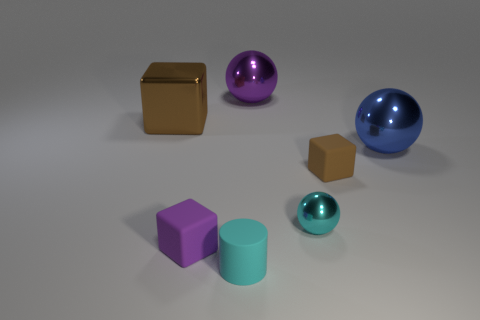What number of purple objects are both in front of the large brown thing and to the right of the tiny cyan matte cylinder?
Give a very brief answer. 0. There is a purple thing that is behind the large blue shiny ball; is it the same size as the cube behind the big blue metallic sphere?
Your response must be concise. Yes. There is a metallic object that is behind the large brown metal cube; what is its size?
Your response must be concise. Large. What number of things are shiny balls that are behind the large shiny block or matte objects on the right side of the purple cube?
Make the answer very short. 3. Is there any other thing that has the same color as the cylinder?
Offer a very short reply. Yes. Are there an equal number of tiny cubes that are behind the large blue object and brown cubes that are on the left side of the small cyan rubber thing?
Your response must be concise. No. Are there more small blocks on the right side of the cyan ball than small green matte cubes?
Offer a terse response. Yes. What number of objects are either cyan objects that are behind the purple rubber thing or cyan metallic spheres?
Provide a succinct answer. 1. How many large brown things are made of the same material as the tiny purple block?
Offer a terse response. 0. What is the shape of the object that is the same color as the shiny cube?
Your response must be concise. Cube. 